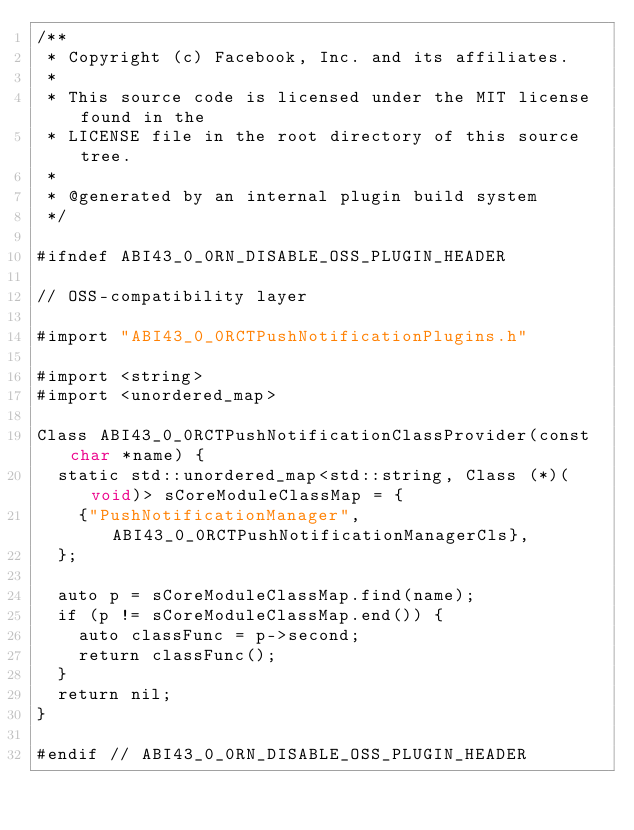<code> <loc_0><loc_0><loc_500><loc_500><_ObjectiveC_>/**
 * Copyright (c) Facebook, Inc. and its affiliates.
 *
 * This source code is licensed under the MIT license found in the
 * LICENSE file in the root directory of this source tree.
 *
 * @generated by an internal plugin build system
 */

#ifndef ABI43_0_0RN_DISABLE_OSS_PLUGIN_HEADER

// OSS-compatibility layer

#import "ABI43_0_0RCTPushNotificationPlugins.h"

#import <string>
#import <unordered_map>

Class ABI43_0_0RCTPushNotificationClassProvider(const char *name) {
  static std::unordered_map<std::string, Class (*)(void)> sCoreModuleClassMap = {
    {"PushNotificationManager", ABI43_0_0RCTPushNotificationManagerCls},
  };

  auto p = sCoreModuleClassMap.find(name);
  if (p != sCoreModuleClassMap.end()) {
    auto classFunc = p->second;
    return classFunc();
  }
  return nil;
}

#endif // ABI43_0_0RN_DISABLE_OSS_PLUGIN_HEADER
</code> 